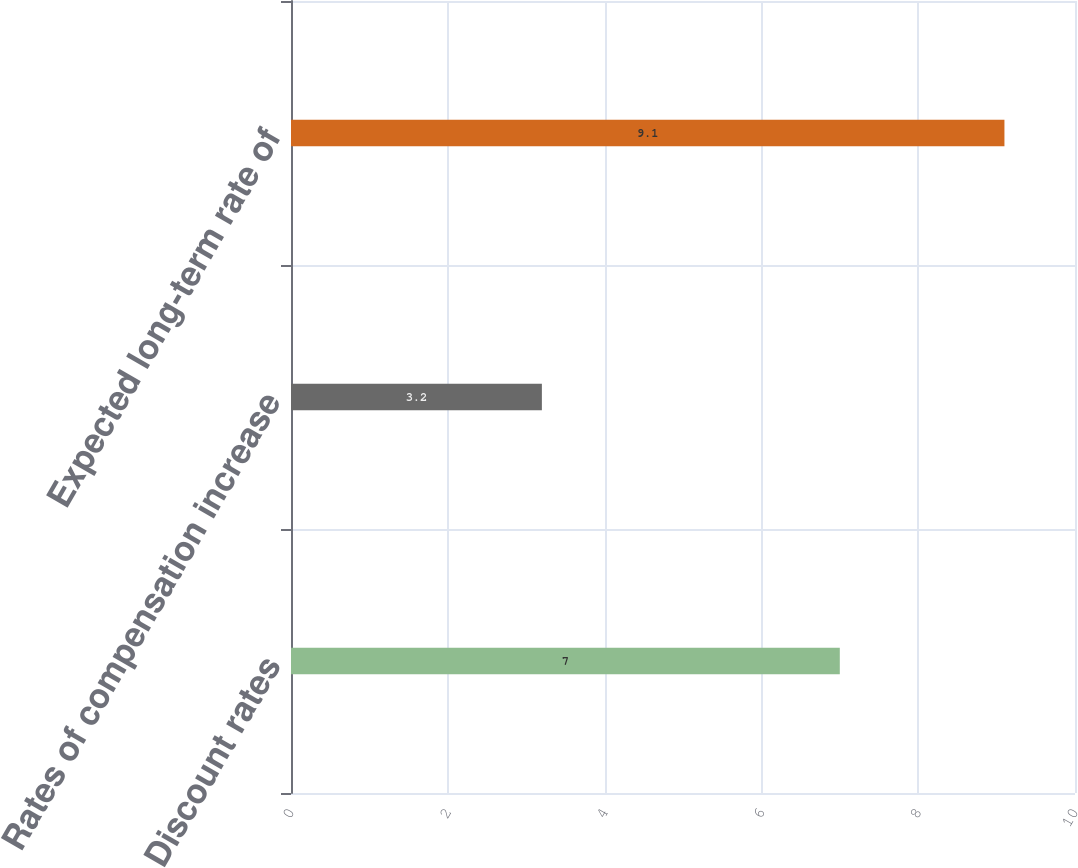Convert chart. <chart><loc_0><loc_0><loc_500><loc_500><bar_chart><fcel>Discount rates<fcel>Rates of compensation increase<fcel>Expected long-term rate of<nl><fcel>7<fcel>3.2<fcel>9.1<nl></chart> 